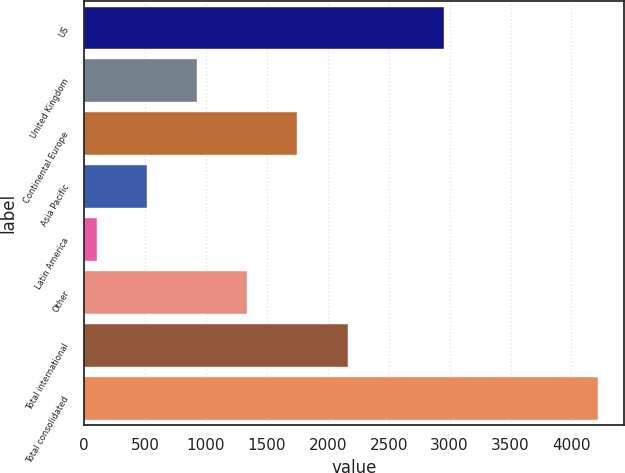Convert chart to OTSL. <chart><loc_0><loc_0><loc_500><loc_500><bar_chart><fcel>US<fcel>United Kingdom<fcel>Continental Europe<fcel>Asia Pacific<fcel>Latin America<fcel>Other<fcel>Total international<fcel>Total consolidated<nl><fcel>2950<fcel>928.02<fcel>1751.24<fcel>516.41<fcel>104.8<fcel>1339.63<fcel>2162.85<fcel>4220.9<nl></chart> 